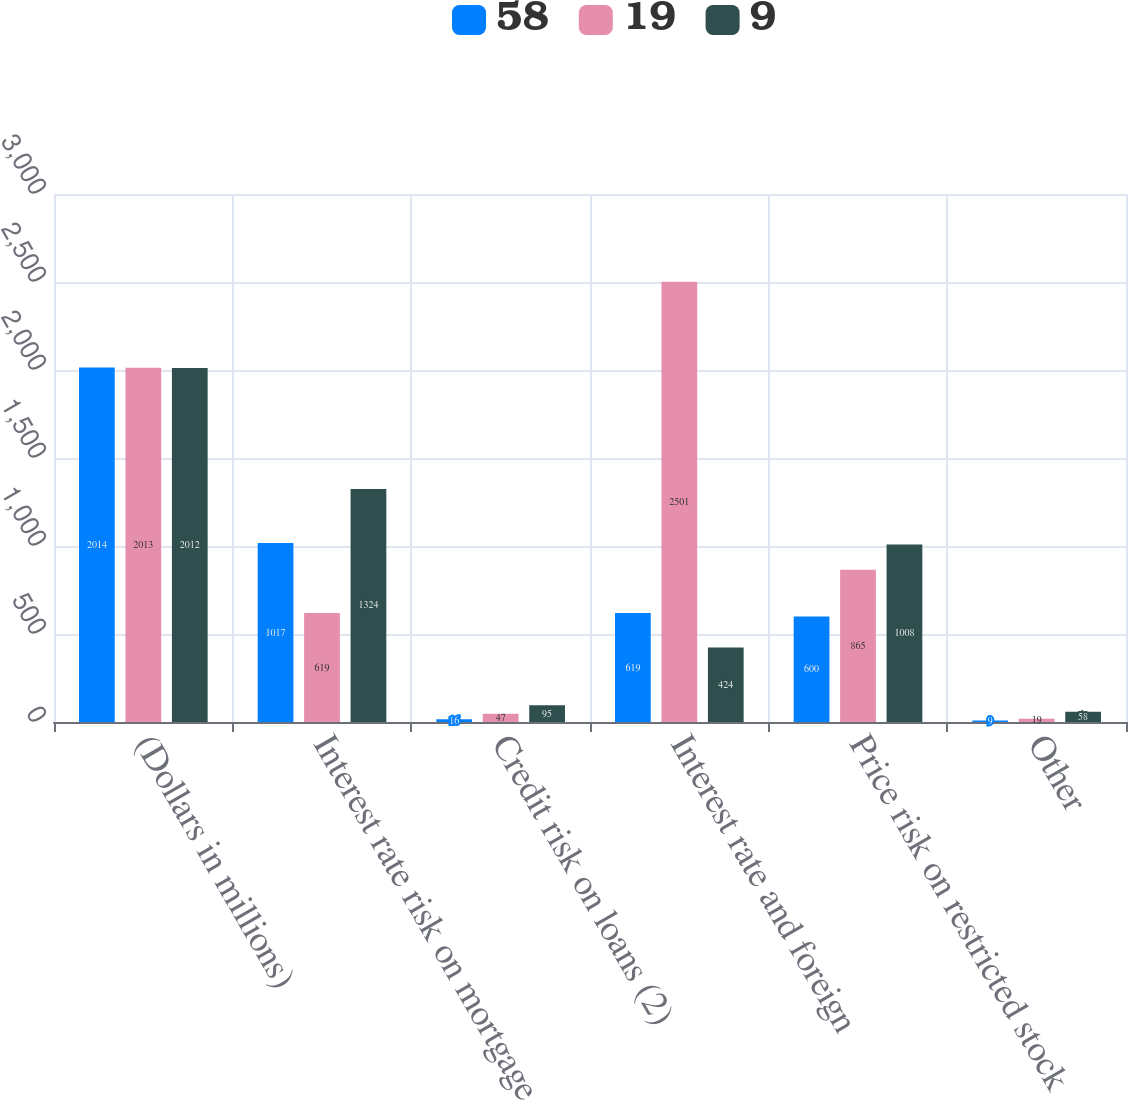Convert chart. <chart><loc_0><loc_0><loc_500><loc_500><stacked_bar_chart><ecel><fcel>(Dollars in millions)<fcel>Interest rate risk on mortgage<fcel>Credit risk on loans (2)<fcel>Interest rate and foreign<fcel>Price risk on restricted stock<fcel>Other<nl><fcel>58<fcel>2014<fcel>1017<fcel>16<fcel>619<fcel>600<fcel>9<nl><fcel>19<fcel>2013<fcel>619<fcel>47<fcel>2501<fcel>865<fcel>19<nl><fcel>9<fcel>2012<fcel>1324<fcel>95<fcel>424<fcel>1008<fcel>58<nl></chart> 